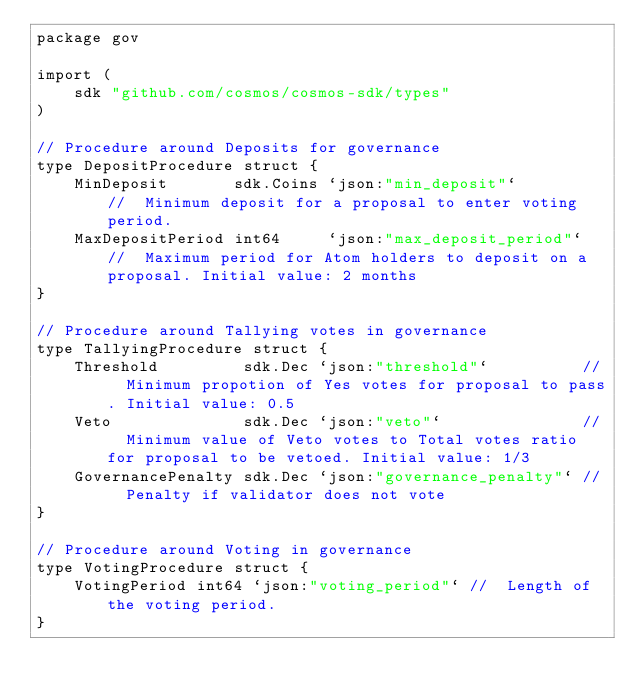Convert code to text. <code><loc_0><loc_0><loc_500><loc_500><_Go_>package gov

import (
	sdk "github.com/cosmos/cosmos-sdk/types"
)

// Procedure around Deposits for governance
type DepositProcedure struct {
	MinDeposit       sdk.Coins `json:"min_deposit"`        //  Minimum deposit for a proposal to enter voting period.
	MaxDepositPeriod int64     `json:"max_deposit_period"` //  Maximum period for Atom holders to deposit on a proposal. Initial value: 2 months
}

// Procedure around Tallying votes in governance
type TallyingProcedure struct {
	Threshold         sdk.Dec `json:"threshold"`          //  Minimum propotion of Yes votes for proposal to pass. Initial value: 0.5
	Veto              sdk.Dec `json:"veto"`               //  Minimum value of Veto votes to Total votes ratio for proposal to be vetoed. Initial value: 1/3
	GovernancePenalty sdk.Dec `json:"governance_penalty"` //  Penalty if validator does not vote
}

// Procedure around Voting in governance
type VotingProcedure struct {
	VotingPeriod int64 `json:"voting_period"` //  Length of the voting period.
}
</code> 